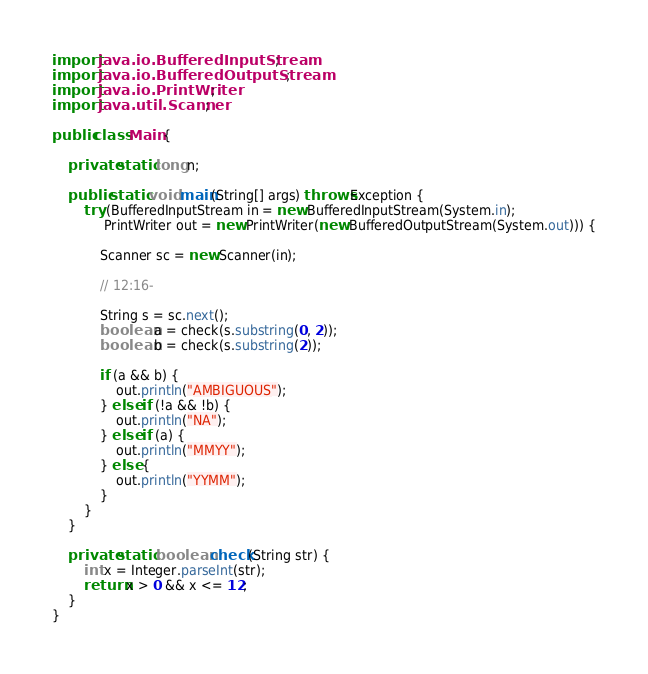Convert code to text. <code><loc_0><loc_0><loc_500><loc_500><_Java_>import java.io.BufferedInputStream;
import java.io.BufferedOutputStream;
import java.io.PrintWriter;
import java.util.Scanner;

public class Main {

    private static long n;

    public static void main(String[] args) throws Exception {
        try (BufferedInputStream in = new BufferedInputStream(System.in);
             PrintWriter out = new PrintWriter(new BufferedOutputStream(System.out))) {

            Scanner sc = new Scanner(in);

            // 12:16-

            String s = sc.next();
            boolean a = check(s.substring(0, 2));
            boolean b = check(s.substring(2));

            if (a && b) {
                out.println("AMBIGUOUS");
            } else if (!a && !b) {
                out.println("NA");
            } else if (a) {
                out.println("MMYY");
            } else {
                out.println("YYMM");
            }
        }
    }

    private static boolean check(String str) {
        int x = Integer.parseInt(str);
        return x > 0 && x <= 12;
    }
}
</code> 